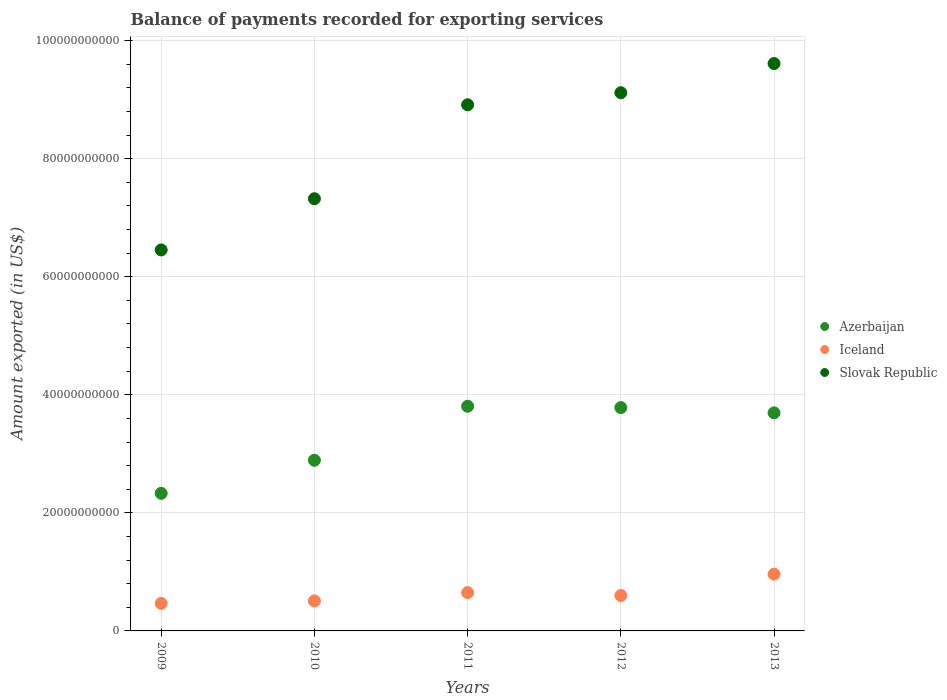What is the amount exported in Azerbaijan in 2013?
Offer a terse response. 3.69e+1. Across all years, what is the maximum amount exported in Azerbaijan?
Offer a very short reply. 3.81e+1. Across all years, what is the minimum amount exported in Slovak Republic?
Provide a succinct answer. 6.45e+1. In which year was the amount exported in Slovak Republic maximum?
Your answer should be very brief. 2013. What is the total amount exported in Iceland in the graph?
Your answer should be very brief. 3.19e+1. What is the difference between the amount exported in Slovak Republic in 2009 and that in 2012?
Ensure brevity in your answer.  -2.66e+1. What is the difference between the amount exported in Slovak Republic in 2012 and the amount exported in Iceland in 2009?
Make the answer very short. 8.65e+1. What is the average amount exported in Slovak Republic per year?
Provide a short and direct response. 8.28e+1. In the year 2013, what is the difference between the amount exported in Slovak Republic and amount exported in Azerbaijan?
Provide a succinct answer. 5.92e+1. What is the ratio of the amount exported in Azerbaijan in 2010 to that in 2013?
Offer a very short reply. 0.78. Is the difference between the amount exported in Slovak Republic in 2010 and 2013 greater than the difference between the amount exported in Azerbaijan in 2010 and 2013?
Offer a terse response. No. What is the difference between the highest and the second highest amount exported in Azerbaijan?
Your answer should be very brief. 2.20e+08. What is the difference between the highest and the lowest amount exported in Azerbaijan?
Offer a very short reply. 1.47e+1. Is the sum of the amount exported in Azerbaijan in 2009 and 2010 greater than the maximum amount exported in Slovak Republic across all years?
Offer a very short reply. No. Does the amount exported in Iceland monotonically increase over the years?
Your answer should be very brief. No. Is the amount exported in Azerbaijan strictly less than the amount exported in Iceland over the years?
Provide a succinct answer. No. Are the values on the major ticks of Y-axis written in scientific E-notation?
Your response must be concise. No. Does the graph contain any zero values?
Make the answer very short. No. Does the graph contain grids?
Your response must be concise. Yes. Where does the legend appear in the graph?
Keep it short and to the point. Center right. How many legend labels are there?
Provide a short and direct response. 3. How are the legend labels stacked?
Your response must be concise. Vertical. What is the title of the graph?
Offer a very short reply. Balance of payments recorded for exporting services. Does "Cambodia" appear as one of the legend labels in the graph?
Offer a terse response. No. What is the label or title of the Y-axis?
Offer a very short reply. Amount exported (in US$). What is the Amount exported (in US$) in Azerbaijan in 2009?
Provide a succinct answer. 2.33e+1. What is the Amount exported (in US$) in Iceland in 2009?
Your response must be concise. 4.67e+09. What is the Amount exported (in US$) of Slovak Republic in 2009?
Offer a very short reply. 6.45e+1. What is the Amount exported (in US$) in Azerbaijan in 2010?
Your response must be concise. 2.89e+1. What is the Amount exported (in US$) of Iceland in 2010?
Offer a terse response. 5.08e+09. What is the Amount exported (in US$) of Slovak Republic in 2010?
Provide a short and direct response. 7.32e+1. What is the Amount exported (in US$) of Azerbaijan in 2011?
Your answer should be very brief. 3.81e+1. What is the Amount exported (in US$) of Iceland in 2011?
Provide a short and direct response. 6.49e+09. What is the Amount exported (in US$) in Slovak Republic in 2011?
Ensure brevity in your answer.  8.91e+1. What is the Amount exported (in US$) in Azerbaijan in 2012?
Make the answer very short. 3.78e+1. What is the Amount exported (in US$) of Iceland in 2012?
Provide a succinct answer. 6.00e+09. What is the Amount exported (in US$) of Slovak Republic in 2012?
Your answer should be very brief. 9.12e+1. What is the Amount exported (in US$) of Azerbaijan in 2013?
Give a very brief answer. 3.69e+1. What is the Amount exported (in US$) of Iceland in 2013?
Provide a short and direct response. 9.62e+09. What is the Amount exported (in US$) in Slovak Republic in 2013?
Make the answer very short. 9.61e+1. Across all years, what is the maximum Amount exported (in US$) in Azerbaijan?
Provide a succinct answer. 3.81e+1. Across all years, what is the maximum Amount exported (in US$) in Iceland?
Make the answer very short. 9.62e+09. Across all years, what is the maximum Amount exported (in US$) in Slovak Republic?
Your answer should be very brief. 9.61e+1. Across all years, what is the minimum Amount exported (in US$) of Azerbaijan?
Ensure brevity in your answer.  2.33e+1. Across all years, what is the minimum Amount exported (in US$) in Iceland?
Your answer should be very brief. 4.67e+09. Across all years, what is the minimum Amount exported (in US$) in Slovak Republic?
Offer a very short reply. 6.45e+1. What is the total Amount exported (in US$) of Azerbaijan in the graph?
Ensure brevity in your answer.  1.65e+11. What is the total Amount exported (in US$) in Iceland in the graph?
Offer a very short reply. 3.19e+1. What is the total Amount exported (in US$) of Slovak Republic in the graph?
Provide a succinct answer. 4.14e+11. What is the difference between the Amount exported (in US$) of Azerbaijan in 2009 and that in 2010?
Offer a terse response. -5.60e+09. What is the difference between the Amount exported (in US$) of Iceland in 2009 and that in 2010?
Your answer should be very brief. -4.17e+08. What is the difference between the Amount exported (in US$) in Slovak Republic in 2009 and that in 2010?
Keep it short and to the point. -8.68e+09. What is the difference between the Amount exported (in US$) of Azerbaijan in 2009 and that in 2011?
Your answer should be compact. -1.47e+1. What is the difference between the Amount exported (in US$) in Iceland in 2009 and that in 2011?
Provide a succinct answer. -1.82e+09. What is the difference between the Amount exported (in US$) in Slovak Republic in 2009 and that in 2011?
Your response must be concise. -2.46e+1. What is the difference between the Amount exported (in US$) of Azerbaijan in 2009 and that in 2012?
Offer a very short reply. -1.45e+1. What is the difference between the Amount exported (in US$) of Iceland in 2009 and that in 2012?
Offer a terse response. -1.33e+09. What is the difference between the Amount exported (in US$) of Slovak Republic in 2009 and that in 2012?
Make the answer very short. -2.66e+1. What is the difference between the Amount exported (in US$) in Azerbaijan in 2009 and that in 2013?
Ensure brevity in your answer.  -1.36e+1. What is the difference between the Amount exported (in US$) of Iceland in 2009 and that in 2013?
Keep it short and to the point. -4.95e+09. What is the difference between the Amount exported (in US$) of Slovak Republic in 2009 and that in 2013?
Offer a terse response. -3.16e+1. What is the difference between the Amount exported (in US$) of Azerbaijan in 2010 and that in 2011?
Keep it short and to the point. -9.15e+09. What is the difference between the Amount exported (in US$) in Iceland in 2010 and that in 2011?
Provide a succinct answer. -1.40e+09. What is the difference between the Amount exported (in US$) of Slovak Republic in 2010 and that in 2011?
Your answer should be compact. -1.59e+1. What is the difference between the Amount exported (in US$) in Azerbaijan in 2010 and that in 2012?
Offer a very short reply. -8.93e+09. What is the difference between the Amount exported (in US$) in Iceland in 2010 and that in 2012?
Your response must be concise. -9.18e+08. What is the difference between the Amount exported (in US$) of Slovak Republic in 2010 and that in 2012?
Provide a short and direct response. -1.80e+1. What is the difference between the Amount exported (in US$) in Azerbaijan in 2010 and that in 2013?
Your response must be concise. -8.03e+09. What is the difference between the Amount exported (in US$) in Iceland in 2010 and that in 2013?
Provide a short and direct response. -4.53e+09. What is the difference between the Amount exported (in US$) of Slovak Republic in 2010 and that in 2013?
Provide a short and direct response. -2.29e+1. What is the difference between the Amount exported (in US$) of Azerbaijan in 2011 and that in 2012?
Your answer should be compact. 2.20e+08. What is the difference between the Amount exported (in US$) in Iceland in 2011 and that in 2012?
Provide a succinct answer. 4.83e+08. What is the difference between the Amount exported (in US$) in Slovak Republic in 2011 and that in 2012?
Make the answer very short. -2.05e+09. What is the difference between the Amount exported (in US$) of Azerbaijan in 2011 and that in 2013?
Your answer should be very brief. 1.12e+09. What is the difference between the Amount exported (in US$) in Iceland in 2011 and that in 2013?
Offer a very short reply. -3.13e+09. What is the difference between the Amount exported (in US$) of Slovak Republic in 2011 and that in 2013?
Offer a very short reply. -6.98e+09. What is the difference between the Amount exported (in US$) in Azerbaijan in 2012 and that in 2013?
Offer a very short reply. 8.96e+08. What is the difference between the Amount exported (in US$) in Iceland in 2012 and that in 2013?
Make the answer very short. -3.61e+09. What is the difference between the Amount exported (in US$) of Slovak Republic in 2012 and that in 2013?
Offer a terse response. -4.94e+09. What is the difference between the Amount exported (in US$) in Azerbaijan in 2009 and the Amount exported (in US$) in Iceland in 2010?
Offer a very short reply. 1.82e+1. What is the difference between the Amount exported (in US$) in Azerbaijan in 2009 and the Amount exported (in US$) in Slovak Republic in 2010?
Your response must be concise. -4.99e+1. What is the difference between the Amount exported (in US$) in Iceland in 2009 and the Amount exported (in US$) in Slovak Republic in 2010?
Make the answer very short. -6.85e+1. What is the difference between the Amount exported (in US$) in Azerbaijan in 2009 and the Amount exported (in US$) in Iceland in 2011?
Keep it short and to the point. 1.68e+1. What is the difference between the Amount exported (in US$) in Azerbaijan in 2009 and the Amount exported (in US$) in Slovak Republic in 2011?
Make the answer very short. -6.58e+1. What is the difference between the Amount exported (in US$) of Iceland in 2009 and the Amount exported (in US$) of Slovak Republic in 2011?
Offer a very short reply. -8.45e+1. What is the difference between the Amount exported (in US$) in Azerbaijan in 2009 and the Amount exported (in US$) in Iceland in 2012?
Give a very brief answer. 1.73e+1. What is the difference between the Amount exported (in US$) in Azerbaijan in 2009 and the Amount exported (in US$) in Slovak Republic in 2012?
Give a very brief answer. -6.79e+1. What is the difference between the Amount exported (in US$) in Iceland in 2009 and the Amount exported (in US$) in Slovak Republic in 2012?
Your answer should be very brief. -8.65e+1. What is the difference between the Amount exported (in US$) in Azerbaijan in 2009 and the Amount exported (in US$) in Iceland in 2013?
Your answer should be very brief. 1.37e+1. What is the difference between the Amount exported (in US$) in Azerbaijan in 2009 and the Amount exported (in US$) in Slovak Republic in 2013?
Keep it short and to the point. -7.28e+1. What is the difference between the Amount exported (in US$) of Iceland in 2009 and the Amount exported (in US$) of Slovak Republic in 2013?
Offer a very short reply. -9.14e+1. What is the difference between the Amount exported (in US$) in Azerbaijan in 2010 and the Amount exported (in US$) in Iceland in 2011?
Keep it short and to the point. 2.24e+1. What is the difference between the Amount exported (in US$) in Azerbaijan in 2010 and the Amount exported (in US$) in Slovak Republic in 2011?
Provide a short and direct response. -6.02e+1. What is the difference between the Amount exported (in US$) in Iceland in 2010 and the Amount exported (in US$) in Slovak Republic in 2011?
Your answer should be very brief. -8.40e+1. What is the difference between the Amount exported (in US$) in Azerbaijan in 2010 and the Amount exported (in US$) in Iceland in 2012?
Your response must be concise. 2.29e+1. What is the difference between the Amount exported (in US$) in Azerbaijan in 2010 and the Amount exported (in US$) in Slovak Republic in 2012?
Provide a succinct answer. -6.23e+1. What is the difference between the Amount exported (in US$) of Iceland in 2010 and the Amount exported (in US$) of Slovak Republic in 2012?
Your answer should be compact. -8.61e+1. What is the difference between the Amount exported (in US$) in Azerbaijan in 2010 and the Amount exported (in US$) in Iceland in 2013?
Offer a terse response. 1.93e+1. What is the difference between the Amount exported (in US$) in Azerbaijan in 2010 and the Amount exported (in US$) in Slovak Republic in 2013?
Provide a short and direct response. -6.72e+1. What is the difference between the Amount exported (in US$) of Iceland in 2010 and the Amount exported (in US$) of Slovak Republic in 2013?
Provide a succinct answer. -9.10e+1. What is the difference between the Amount exported (in US$) in Azerbaijan in 2011 and the Amount exported (in US$) in Iceland in 2012?
Your answer should be very brief. 3.21e+1. What is the difference between the Amount exported (in US$) of Azerbaijan in 2011 and the Amount exported (in US$) of Slovak Republic in 2012?
Your answer should be very brief. -5.31e+1. What is the difference between the Amount exported (in US$) of Iceland in 2011 and the Amount exported (in US$) of Slovak Republic in 2012?
Provide a succinct answer. -8.47e+1. What is the difference between the Amount exported (in US$) of Azerbaijan in 2011 and the Amount exported (in US$) of Iceland in 2013?
Make the answer very short. 2.84e+1. What is the difference between the Amount exported (in US$) in Azerbaijan in 2011 and the Amount exported (in US$) in Slovak Republic in 2013?
Offer a very short reply. -5.81e+1. What is the difference between the Amount exported (in US$) of Iceland in 2011 and the Amount exported (in US$) of Slovak Republic in 2013?
Make the answer very short. -8.96e+1. What is the difference between the Amount exported (in US$) in Azerbaijan in 2012 and the Amount exported (in US$) in Iceland in 2013?
Keep it short and to the point. 2.82e+1. What is the difference between the Amount exported (in US$) of Azerbaijan in 2012 and the Amount exported (in US$) of Slovak Republic in 2013?
Provide a succinct answer. -5.83e+1. What is the difference between the Amount exported (in US$) of Iceland in 2012 and the Amount exported (in US$) of Slovak Republic in 2013?
Provide a succinct answer. -9.01e+1. What is the average Amount exported (in US$) in Azerbaijan per year?
Ensure brevity in your answer.  3.30e+1. What is the average Amount exported (in US$) of Iceland per year?
Your response must be concise. 6.37e+09. What is the average Amount exported (in US$) in Slovak Republic per year?
Ensure brevity in your answer.  8.28e+1. In the year 2009, what is the difference between the Amount exported (in US$) of Azerbaijan and Amount exported (in US$) of Iceland?
Ensure brevity in your answer.  1.86e+1. In the year 2009, what is the difference between the Amount exported (in US$) of Azerbaijan and Amount exported (in US$) of Slovak Republic?
Give a very brief answer. -4.12e+1. In the year 2009, what is the difference between the Amount exported (in US$) in Iceland and Amount exported (in US$) in Slovak Republic?
Your answer should be compact. -5.99e+1. In the year 2010, what is the difference between the Amount exported (in US$) in Azerbaijan and Amount exported (in US$) in Iceland?
Ensure brevity in your answer.  2.38e+1. In the year 2010, what is the difference between the Amount exported (in US$) in Azerbaijan and Amount exported (in US$) in Slovak Republic?
Your response must be concise. -4.43e+1. In the year 2010, what is the difference between the Amount exported (in US$) in Iceland and Amount exported (in US$) in Slovak Republic?
Offer a terse response. -6.81e+1. In the year 2011, what is the difference between the Amount exported (in US$) of Azerbaijan and Amount exported (in US$) of Iceland?
Give a very brief answer. 3.16e+1. In the year 2011, what is the difference between the Amount exported (in US$) in Azerbaijan and Amount exported (in US$) in Slovak Republic?
Offer a terse response. -5.11e+1. In the year 2011, what is the difference between the Amount exported (in US$) of Iceland and Amount exported (in US$) of Slovak Republic?
Your answer should be compact. -8.26e+1. In the year 2012, what is the difference between the Amount exported (in US$) of Azerbaijan and Amount exported (in US$) of Iceland?
Provide a succinct answer. 3.18e+1. In the year 2012, what is the difference between the Amount exported (in US$) in Azerbaijan and Amount exported (in US$) in Slovak Republic?
Ensure brevity in your answer.  -5.33e+1. In the year 2012, what is the difference between the Amount exported (in US$) in Iceland and Amount exported (in US$) in Slovak Republic?
Offer a terse response. -8.52e+1. In the year 2013, what is the difference between the Amount exported (in US$) of Azerbaijan and Amount exported (in US$) of Iceland?
Your answer should be compact. 2.73e+1. In the year 2013, what is the difference between the Amount exported (in US$) in Azerbaijan and Amount exported (in US$) in Slovak Republic?
Your answer should be very brief. -5.92e+1. In the year 2013, what is the difference between the Amount exported (in US$) of Iceland and Amount exported (in US$) of Slovak Republic?
Provide a short and direct response. -8.65e+1. What is the ratio of the Amount exported (in US$) in Azerbaijan in 2009 to that in 2010?
Provide a short and direct response. 0.81. What is the ratio of the Amount exported (in US$) of Iceland in 2009 to that in 2010?
Keep it short and to the point. 0.92. What is the ratio of the Amount exported (in US$) of Slovak Republic in 2009 to that in 2010?
Make the answer very short. 0.88. What is the ratio of the Amount exported (in US$) in Azerbaijan in 2009 to that in 2011?
Keep it short and to the point. 0.61. What is the ratio of the Amount exported (in US$) of Iceland in 2009 to that in 2011?
Provide a short and direct response. 0.72. What is the ratio of the Amount exported (in US$) in Slovak Republic in 2009 to that in 2011?
Provide a succinct answer. 0.72. What is the ratio of the Amount exported (in US$) in Azerbaijan in 2009 to that in 2012?
Your response must be concise. 0.62. What is the ratio of the Amount exported (in US$) of Iceland in 2009 to that in 2012?
Your answer should be very brief. 0.78. What is the ratio of the Amount exported (in US$) of Slovak Republic in 2009 to that in 2012?
Your answer should be compact. 0.71. What is the ratio of the Amount exported (in US$) in Azerbaijan in 2009 to that in 2013?
Your response must be concise. 0.63. What is the ratio of the Amount exported (in US$) in Iceland in 2009 to that in 2013?
Provide a short and direct response. 0.49. What is the ratio of the Amount exported (in US$) in Slovak Republic in 2009 to that in 2013?
Offer a terse response. 0.67. What is the ratio of the Amount exported (in US$) of Azerbaijan in 2010 to that in 2011?
Offer a very short reply. 0.76. What is the ratio of the Amount exported (in US$) in Iceland in 2010 to that in 2011?
Ensure brevity in your answer.  0.78. What is the ratio of the Amount exported (in US$) of Slovak Republic in 2010 to that in 2011?
Offer a terse response. 0.82. What is the ratio of the Amount exported (in US$) of Azerbaijan in 2010 to that in 2012?
Your answer should be very brief. 0.76. What is the ratio of the Amount exported (in US$) in Iceland in 2010 to that in 2012?
Provide a short and direct response. 0.85. What is the ratio of the Amount exported (in US$) in Slovak Republic in 2010 to that in 2012?
Give a very brief answer. 0.8. What is the ratio of the Amount exported (in US$) of Azerbaijan in 2010 to that in 2013?
Provide a short and direct response. 0.78. What is the ratio of the Amount exported (in US$) in Iceland in 2010 to that in 2013?
Provide a succinct answer. 0.53. What is the ratio of the Amount exported (in US$) in Slovak Republic in 2010 to that in 2013?
Offer a very short reply. 0.76. What is the ratio of the Amount exported (in US$) of Azerbaijan in 2011 to that in 2012?
Give a very brief answer. 1.01. What is the ratio of the Amount exported (in US$) in Iceland in 2011 to that in 2012?
Make the answer very short. 1.08. What is the ratio of the Amount exported (in US$) of Slovak Republic in 2011 to that in 2012?
Your response must be concise. 0.98. What is the ratio of the Amount exported (in US$) of Azerbaijan in 2011 to that in 2013?
Ensure brevity in your answer.  1.03. What is the ratio of the Amount exported (in US$) of Iceland in 2011 to that in 2013?
Your response must be concise. 0.67. What is the ratio of the Amount exported (in US$) in Slovak Republic in 2011 to that in 2013?
Offer a very short reply. 0.93. What is the ratio of the Amount exported (in US$) in Azerbaijan in 2012 to that in 2013?
Keep it short and to the point. 1.02. What is the ratio of the Amount exported (in US$) in Iceland in 2012 to that in 2013?
Provide a short and direct response. 0.62. What is the ratio of the Amount exported (in US$) in Slovak Republic in 2012 to that in 2013?
Provide a short and direct response. 0.95. What is the difference between the highest and the second highest Amount exported (in US$) in Azerbaijan?
Offer a terse response. 2.20e+08. What is the difference between the highest and the second highest Amount exported (in US$) in Iceland?
Your answer should be very brief. 3.13e+09. What is the difference between the highest and the second highest Amount exported (in US$) of Slovak Republic?
Your response must be concise. 4.94e+09. What is the difference between the highest and the lowest Amount exported (in US$) of Azerbaijan?
Offer a terse response. 1.47e+1. What is the difference between the highest and the lowest Amount exported (in US$) in Iceland?
Provide a succinct answer. 4.95e+09. What is the difference between the highest and the lowest Amount exported (in US$) in Slovak Republic?
Offer a terse response. 3.16e+1. 